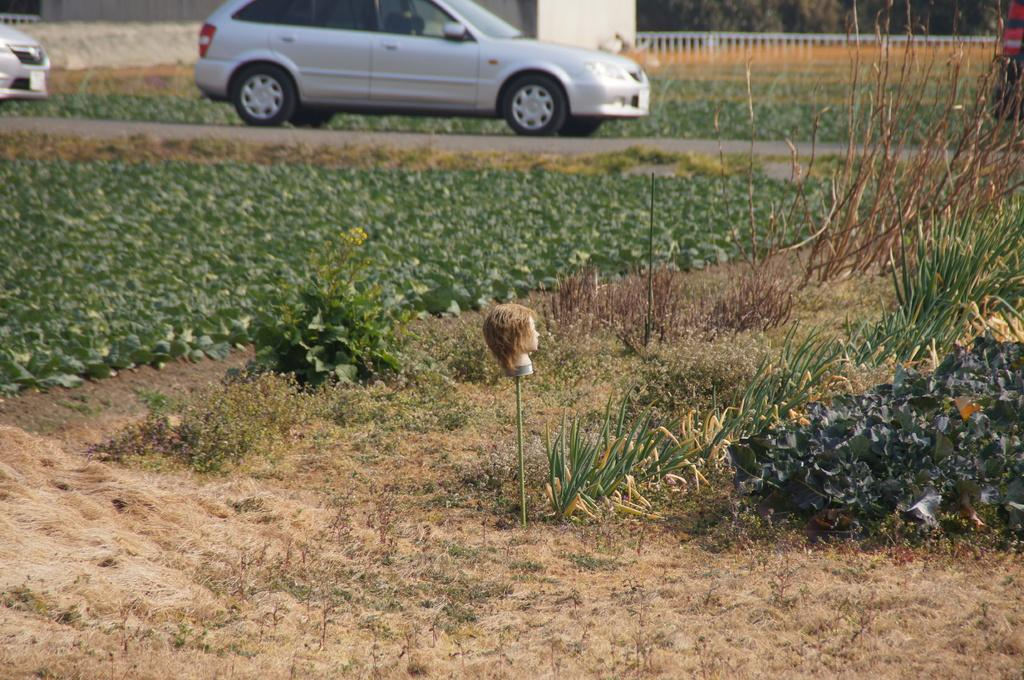What is the main object in the image? There is a doll's head on a stick in the image. What type of natural environment is depicted in the image? There is grass and plants in the image. What can be seen on the road in the image? There are vehicles on the road in the image. What architectural features are visible in the background of the image? There are iron grills and trees in the background of the image. What type of canvas is being used to create a tent in the image? There is no tent or canvas present in the image; it features a doll's head on a stick, grass, plants, vehicles, iron grills, and trees. What brand of toothpaste is being advertised on the doll's head in the image? There is no toothpaste or advertisement present on the doll's head in the image; it is simply a doll's head on a stick. 